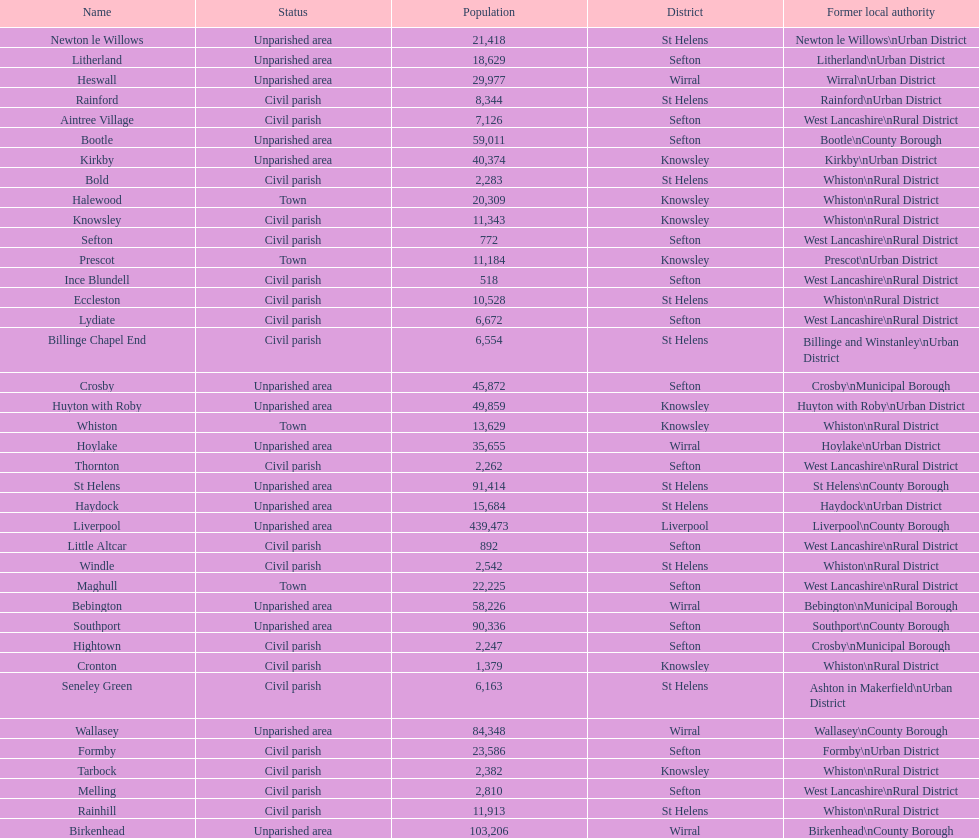How many areas are unparished areas? 15. 